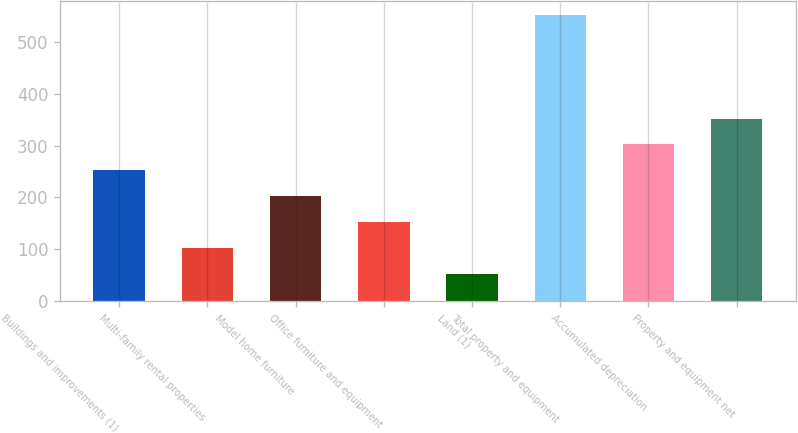<chart> <loc_0><loc_0><loc_500><loc_500><bar_chart><fcel>Buildings and improvements (1)<fcel>Multi-family rental properties<fcel>Model home furniture<fcel>Office furniture and equipment<fcel>Land (1)<fcel>Total property and equipment<fcel>Accumulated depreciation<fcel>Property and equipment net<nl><fcel>252.22<fcel>102.73<fcel>202.39<fcel>152.56<fcel>52.9<fcel>551.2<fcel>302.05<fcel>351.88<nl></chart> 